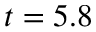Convert formula to latex. <formula><loc_0><loc_0><loc_500><loc_500>t = 5 . 8</formula> 